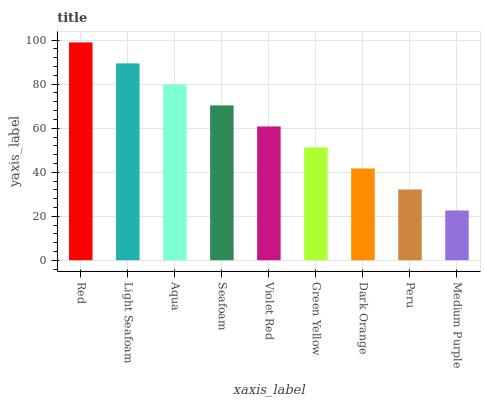Is Medium Purple the minimum?
Answer yes or no. Yes. Is Red the maximum?
Answer yes or no. Yes. Is Light Seafoam the minimum?
Answer yes or no. No. Is Light Seafoam the maximum?
Answer yes or no. No. Is Red greater than Light Seafoam?
Answer yes or no. Yes. Is Light Seafoam less than Red?
Answer yes or no. Yes. Is Light Seafoam greater than Red?
Answer yes or no. No. Is Red less than Light Seafoam?
Answer yes or no. No. Is Violet Red the high median?
Answer yes or no. Yes. Is Violet Red the low median?
Answer yes or no. Yes. Is Light Seafoam the high median?
Answer yes or no. No. Is Light Seafoam the low median?
Answer yes or no. No. 